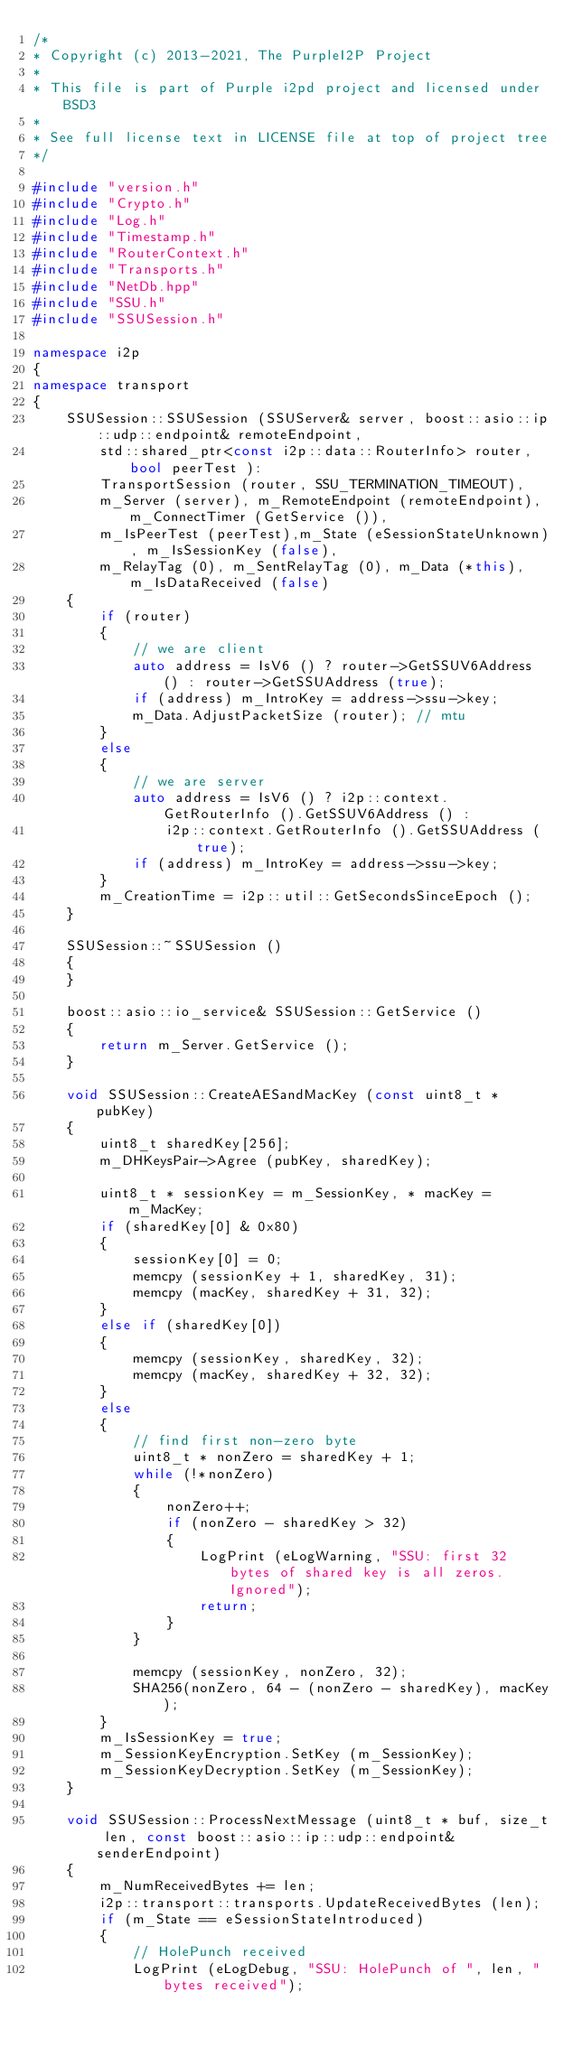Convert code to text. <code><loc_0><loc_0><loc_500><loc_500><_C++_>/*
* Copyright (c) 2013-2021, The PurpleI2P Project
*
* This file is part of Purple i2pd project and licensed under BSD3
*
* See full license text in LICENSE file at top of project tree
*/

#include "version.h"
#include "Crypto.h"
#include "Log.h"
#include "Timestamp.h"
#include "RouterContext.h"
#include "Transports.h"
#include "NetDb.hpp"
#include "SSU.h"
#include "SSUSession.h"

namespace i2p
{
namespace transport
{
	SSUSession::SSUSession (SSUServer& server, boost::asio::ip::udp::endpoint& remoteEndpoint,
		std::shared_ptr<const i2p::data::RouterInfo> router, bool peerTest ):
		TransportSession (router, SSU_TERMINATION_TIMEOUT),
		m_Server (server), m_RemoteEndpoint (remoteEndpoint), m_ConnectTimer (GetService ()),
		m_IsPeerTest (peerTest),m_State (eSessionStateUnknown), m_IsSessionKey (false),
		m_RelayTag (0), m_SentRelayTag (0), m_Data (*this), m_IsDataReceived (false)
	{
		if (router)
		{
			// we are client
			auto address = IsV6 () ? router->GetSSUV6Address () : router->GetSSUAddress (true);
			if (address) m_IntroKey = address->ssu->key;
			m_Data.AdjustPacketSize (router); // mtu
		}
		else
		{
			// we are server
			auto address = IsV6 () ? i2p::context.GetRouterInfo ().GetSSUV6Address () :
				i2p::context.GetRouterInfo ().GetSSUAddress (true);
			if (address) m_IntroKey = address->ssu->key;
		}
		m_CreationTime = i2p::util::GetSecondsSinceEpoch ();
	}

	SSUSession::~SSUSession ()
	{
	}

	boost::asio::io_service& SSUSession::GetService ()
	{
		return m_Server.GetService ();
	}

	void SSUSession::CreateAESandMacKey (const uint8_t * pubKey)
	{
		uint8_t sharedKey[256];
		m_DHKeysPair->Agree (pubKey, sharedKey);

		uint8_t * sessionKey = m_SessionKey, * macKey = m_MacKey;
		if (sharedKey[0] & 0x80)
		{
			sessionKey[0] = 0;
			memcpy (sessionKey + 1, sharedKey, 31);
			memcpy (macKey, sharedKey + 31, 32);
		}
		else if (sharedKey[0])
		{
			memcpy (sessionKey, sharedKey, 32);
			memcpy (macKey, sharedKey + 32, 32);
		}
		else
		{
			// find first non-zero byte
			uint8_t * nonZero = sharedKey + 1;
			while (!*nonZero)
			{
				nonZero++;
				if (nonZero - sharedKey > 32)
				{
					LogPrint (eLogWarning, "SSU: first 32 bytes of shared key is all zeros. Ignored");
					return;
				}
			}

			memcpy (sessionKey, nonZero, 32);
			SHA256(nonZero, 64 - (nonZero - sharedKey), macKey);
		}
		m_IsSessionKey = true;
		m_SessionKeyEncryption.SetKey (m_SessionKey);
		m_SessionKeyDecryption.SetKey (m_SessionKey);
	}

	void SSUSession::ProcessNextMessage (uint8_t * buf, size_t len, const boost::asio::ip::udp::endpoint& senderEndpoint)
	{
		m_NumReceivedBytes += len;
		i2p::transport::transports.UpdateReceivedBytes (len);
		if (m_State == eSessionStateIntroduced)
		{
			// HolePunch received
			LogPrint (eLogDebug, "SSU: HolePunch of ", len, " bytes received");</code> 